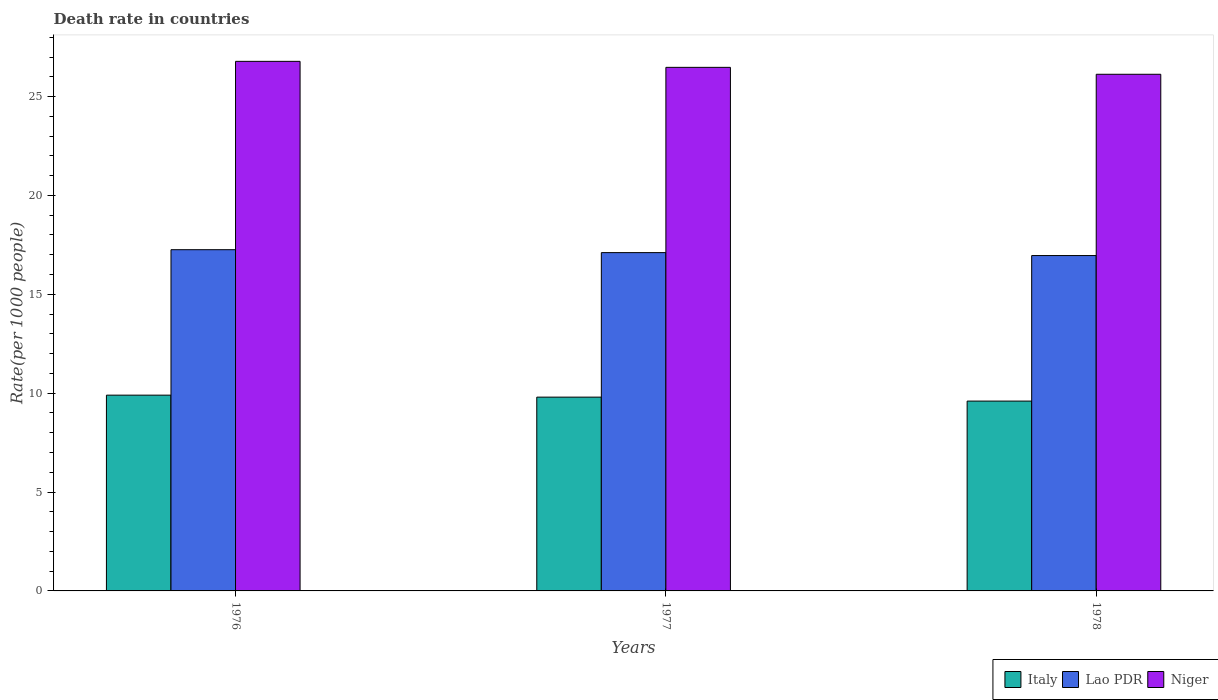How many different coloured bars are there?
Make the answer very short. 3. How many groups of bars are there?
Keep it short and to the point. 3. Are the number of bars per tick equal to the number of legend labels?
Ensure brevity in your answer.  Yes. Are the number of bars on each tick of the X-axis equal?
Offer a terse response. Yes. What is the label of the 1st group of bars from the left?
Your response must be concise. 1976. What is the death rate in Italy in 1977?
Provide a short and direct response. 9.8. Across all years, what is the maximum death rate in Lao PDR?
Your response must be concise. 17.26. Across all years, what is the minimum death rate in Lao PDR?
Provide a succinct answer. 16.96. In which year was the death rate in Lao PDR maximum?
Give a very brief answer. 1976. In which year was the death rate in Italy minimum?
Give a very brief answer. 1978. What is the total death rate in Niger in the graph?
Give a very brief answer. 79.38. What is the difference between the death rate in Italy in 1976 and that in 1978?
Provide a succinct answer. 0.3. What is the difference between the death rate in Lao PDR in 1977 and the death rate in Italy in 1978?
Ensure brevity in your answer.  7.51. What is the average death rate in Niger per year?
Offer a terse response. 26.46. In the year 1978, what is the difference between the death rate in Italy and death rate in Lao PDR?
Your response must be concise. -7.36. What is the ratio of the death rate in Niger in 1977 to that in 1978?
Your answer should be very brief. 1.01. Is the difference between the death rate in Italy in 1977 and 1978 greater than the difference between the death rate in Lao PDR in 1977 and 1978?
Make the answer very short. Yes. What is the difference between the highest and the second highest death rate in Italy?
Your answer should be very brief. 0.1. What is the difference between the highest and the lowest death rate in Niger?
Your answer should be very brief. 0.65. In how many years, is the death rate in Lao PDR greater than the average death rate in Lao PDR taken over all years?
Make the answer very short. 2. What does the 3rd bar from the left in 1978 represents?
Offer a terse response. Niger. What does the 2nd bar from the right in 1977 represents?
Ensure brevity in your answer.  Lao PDR. Is it the case that in every year, the sum of the death rate in Lao PDR and death rate in Niger is greater than the death rate in Italy?
Provide a succinct answer. Yes. How many bars are there?
Offer a terse response. 9. Are all the bars in the graph horizontal?
Ensure brevity in your answer.  No. How many years are there in the graph?
Offer a very short reply. 3. Does the graph contain grids?
Provide a short and direct response. No. How are the legend labels stacked?
Offer a terse response. Horizontal. What is the title of the graph?
Give a very brief answer. Death rate in countries. What is the label or title of the X-axis?
Your answer should be compact. Years. What is the label or title of the Y-axis?
Provide a succinct answer. Rate(per 1000 people). What is the Rate(per 1000 people) in Lao PDR in 1976?
Offer a terse response. 17.26. What is the Rate(per 1000 people) of Niger in 1976?
Make the answer very short. 26.78. What is the Rate(per 1000 people) in Lao PDR in 1977?
Ensure brevity in your answer.  17.11. What is the Rate(per 1000 people) in Niger in 1977?
Provide a succinct answer. 26.48. What is the Rate(per 1000 people) of Lao PDR in 1978?
Your answer should be very brief. 16.96. What is the Rate(per 1000 people) of Niger in 1978?
Offer a very short reply. 26.13. Across all years, what is the maximum Rate(per 1000 people) of Italy?
Make the answer very short. 9.9. Across all years, what is the maximum Rate(per 1000 people) of Lao PDR?
Make the answer very short. 17.26. Across all years, what is the maximum Rate(per 1000 people) of Niger?
Provide a short and direct response. 26.78. Across all years, what is the minimum Rate(per 1000 people) of Italy?
Provide a succinct answer. 9.6. Across all years, what is the minimum Rate(per 1000 people) in Lao PDR?
Give a very brief answer. 16.96. Across all years, what is the minimum Rate(per 1000 people) in Niger?
Your response must be concise. 26.13. What is the total Rate(per 1000 people) of Italy in the graph?
Your answer should be compact. 29.3. What is the total Rate(per 1000 people) of Lao PDR in the graph?
Keep it short and to the point. 51.32. What is the total Rate(per 1000 people) in Niger in the graph?
Offer a terse response. 79.38. What is the difference between the Rate(per 1000 people) in Lao PDR in 1976 and that in 1977?
Your answer should be compact. 0.15. What is the difference between the Rate(per 1000 people) of Niger in 1976 and that in 1977?
Your response must be concise. 0.3. What is the difference between the Rate(per 1000 people) of Lao PDR in 1976 and that in 1978?
Offer a very short reply. 0.3. What is the difference between the Rate(per 1000 people) of Niger in 1976 and that in 1978?
Offer a very short reply. 0.65. What is the difference between the Rate(per 1000 people) of Italy in 1977 and that in 1978?
Your response must be concise. 0.2. What is the difference between the Rate(per 1000 people) of Lao PDR in 1977 and that in 1978?
Your answer should be very brief. 0.15. What is the difference between the Rate(per 1000 people) of Italy in 1976 and the Rate(per 1000 people) of Lao PDR in 1977?
Ensure brevity in your answer.  -7.21. What is the difference between the Rate(per 1000 people) of Italy in 1976 and the Rate(per 1000 people) of Niger in 1977?
Your response must be concise. -16.58. What is the difference between the Rate(per 1000 people) in Lao PDR in 1976 and the Rate(per 1000 people) in Niger in 1977?
Provide a succinct answer. -9.22. What is the difference between the Rate(per 1000 people) in Italy in 1976 and the Rate(per 1000 people) in Lao PDR in 1978?
Your answer should be very brief. -7.06. What is the difference between the Rate(per 1000 people) of Italy in 1976 and the Rate(per 1000 people) of Niger in 1978?
Keep it short and to the point. -16.23. What is the difference between the Rate(per 1000 people) in Lao PDR in 1976 and the Rate(per 1000 people) in Niger in 1978?
Provide a short and direct response. -8.87. What is the difference between the Rate(per 1000 people) in Italy in 1977 and the Rate(per 1000 people) in Lao PDR in 1978?
Your answer should be very brief. -7.16. What is the difference between the Rate(per 1000 people) of Italy in 1977 and the Rate(per 1000 people) of Niger in 1978?
Offer a very short reply. -16.33. What is the difference between the Rate(per 1000 people) of Lao PDR in 1977 and the Rate(per 1000 people) of Niger in 1978?
Provide a short and direct response. -9.02. What is the average Rate(per 1000 people) in Italy per year?
Give a very brief answer. 9.77. What is the average Rate(per 1000 people) in Lao PDR per year?
Provide a succinct answer. 17.11. What is the average Rate(per 1000 people) in Niger per year?
Offer a terse response. 26.46. In the year 1976, what is the difference between the Rate(per 1000 people) of Italy and Rate(per 1000 people) of Lao PDR?
Give a very brief answer. -7.36. In the year 1976, what is the difference between the Rate(per 1000 people) in Italy and Rate(per 1000 people) in Niger?
Give a very brief answer. -16.88. In the year 1976, what is the difference between the Rate(per 1000 people) of Lao PDR and Rate(per 1000 people) of Niger?
Your response must be concise. -9.52. In the year 1977, what is the difference between the Rate(per 1000 people) in Italy and Rate(per 1000 people) in Lao PDR?
Provide a short and direct response. -7.31. In the year 1977, what is the difference between the Rate(per 1000 people) of Italy and Rate(per 1000 people) of Niger?
Your response must be concise. -16.68. In the year 1977, what is the difference between the Rate(per 1000 people) in Lao PDR and Rate(per 1000 people) in Niger?
Make the answer very short. -9.37. In the year 1978, what is the difference between the Rate(per 1000 people) of Italy and Rate(per 1000 people) of Lao PDR?
Offer a very short reply. -7.36. In the year 1978, what is the difference between the Rate(per 1000 people) in Italy and Rate(per 1000 people) in Niger?
Offer a very short reply. -16.53. In the year 1978, what is the difference between the Rate(per 1000 people) in Lao PDR and Rate(per 1000 people) in Niger?
Your answer should be compact. -9.17. What is the ratio of the Rate(per 1000 people) in Italy in 1976 to that in 1977?
Ensure brevity in your answer.  1.01. What is the ratio of the Rate(per 1000 people) in Lao PDR in 1976 to that in 1977?
Ensure brevity in your answer.  1.01. What is the ratio of the Rate(per 1000 people) of Niger in 1976 to that in 1977?
Ensure brevity in your answer.  1.01. What is the ratio of the Rate(per 1000 people) in Italy in 1976 to that in 1978?
Offer a very short reply. 1.03. What is the ratio of the Rate(per 1000 people) of Lao PDR in 1976 to that in 1978?
Keep it short and to the point. 1.02. What is the ratio of the Rate(per 1000 people) in Italy in 1977 to that in 1978?
Give a very brief answer. 1.02. What is the ratio of the Rate(per 1000 people) in Lao PDR in 1977 to that in 1978?
Give a very brief answer. 1.01. What is the ratio of the Rate(per 1000 people) of Niger in 1977 to that in 1978?
Your answer should be compact. 1.01. What is the difference between the highest and the second highest Rate(per 1000 people) of Italy?
Your answer should be compact. 0.1. What is the difference between the highest and the second highest Rate(per 1000 people) of Lao PDR?
Your answer should be compact. 0.15. What is the difference between the highest and the second highest Rate(per 1000 people) in Niger?
Your answer should be compact. 0.3. What is the difference between the highest and the lowest Rate(per 1000 people) of Lao PDR?
Provide a short and direct response. 0.3. What is the difference between the highest and the lowest Rate(per 1000 people) of Niger?
Your answer should be very brief. 0.65. 